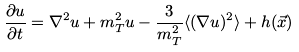<formula> <loc_0><loc_0><loc_500><loc_500>\frac { \partial u } { \partial t } = \nabla ^ { 2 } u + m _ { T } ^ { 2 } u - \frac { 3 } { m _ { T } ^ { 2 } } \langle ( \nabla u ) ^ { 2 } \rangle + h ( \vec { x } )</formula> 